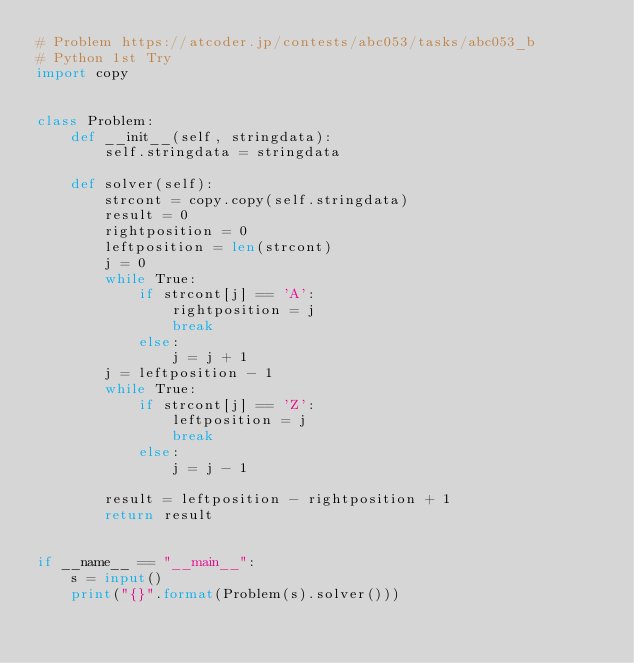<code> <loc_0><loc_0><loc_500><loc_500><_Python_># Problem https://atcoder.jp/contests/abc053/tasks/abc053_b
# Python 1st Try
import copy


class Problem:
    def __init__(self, stringdata):
        self.stringdata = stringdata

    def solver(self):
        strcont = copy.copy(self.stringdata)
        result = 0
        rightposition = 0
        leftposition = len(strcont)
        j = 0
        while True:
            if strcont[j] == 'A':
                rightposition = j
                break
            else:
                j = j + 1
        j = leftposition - 1
        while True:
            if strcont[j] == 'Z':
                leftposition = j
                break
            else:
                j = j - 1

        result = leftposition - rightposition + 1
        return result


if __name__ == "__main__":
    s = input()
    print("{}".format(Problem(s).solver()))
</code> 